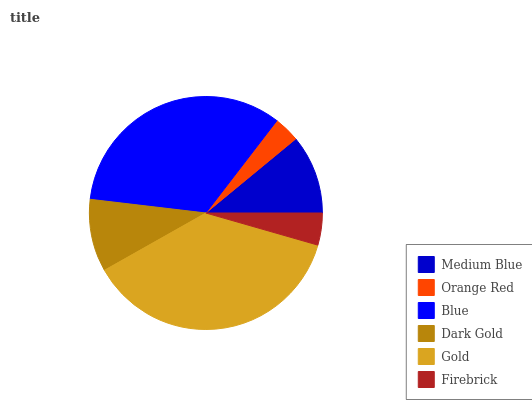Is Orange Red the minimum?
Answer yes or no. Yes. Is Gold the maximum?
Answer yes or no. Yes. Is Blue the minimum?
Answer yes or no. No. Is Blue the maximum?
Answer yes or no. No. Is Blue greater than Orange Red?
Answer yes or no. Yes. Is Orange Red less than Blue?
Answer yes or no. Yes. Is Orange Red greater than Blue?
Answer yes or no. No. Is Blue less than Orange Red?
Answer yes or no. No. Is Medium Blue the high median?
Answer yes or no. Yes. Is Dark Gold the low median?
Answer yes or no. Yes. Is Gold the high median?
Answer yes or no. No. Is Medium Blue the low median?
Answer yes or no. No. 